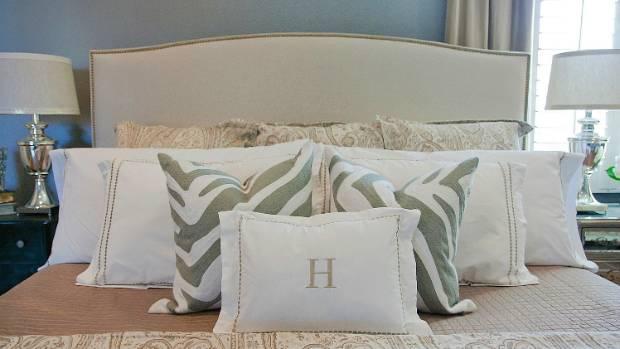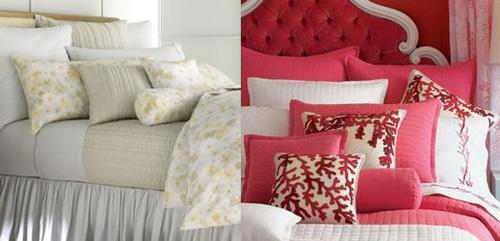The first image is the image on the left, the second image is the image on the right. Considering the images on both sides, is "The bed on the farthest right has mostly solid white pillows." valid? Answer yes or no. No. 